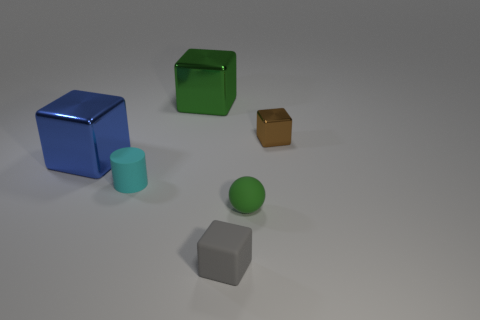What number of big green metallic cubes are there?
Make the answer very short. 1. Do the green object that is on the left side of the green matte object and the small brown cube have the same size?
Provide a short and direct response. No. What number of matte objects are gray cubes or green blocks?
Your answer should be very brief. 1. There is a tiny cube that is left of the small green matte sphere; how many brown objects are to the right of it?
Give a very brief answer. 1. What is the shape of the tiny thing that is right of the gray object and in front of the small cyan rubber cylinder?
Your response must be concise. Sphere. The tiny cube in front of the big shiny cube that is to the left of the metallic cube behind the small brown shiny cube is made of what material?
Provide a succinct answer. Rubber. The metallic object that is the same color as the rubber ball is what size?
Your response must be concise. Large. What is the small cyan object made of?
Ensure brevity in your answer.  Rubber. Is the material of the large green object the same as the green thing in front of the blue metallic block?
Your answer should be very brief. No. There is a large shiny object to the right of the metal object that is on the left side of the small cyan cylinder; what is its color?
Offer a terse response. Green. 